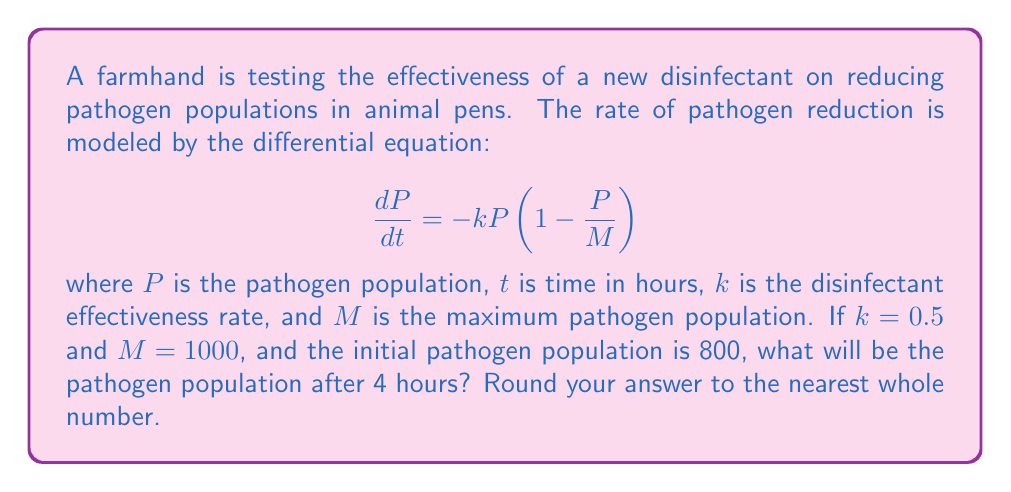Could you help me with this problem? To solve this problem, we need to use the logistic decay model, which is a nonlinear differential equation. Let's approach this step-by-step:

1) The given differential equation is:
   $$\frac{dP}{dt} = -kP(1-\frac{P}{M})$$

2) We're given that $k=0.5$, $M=1000$, and the initial population $P_0=800$.

3) The solution to this differential equation is:
   $$P(t) = \frac{MP_0}{P_0 + (M-P_0)e^{kt}}$$

4) Substituting the known values:
   $$P(t) = \frac{1000 \cdot 800}{800 + (1000-800)e^{0.5t}}$$

5) Simplify:
   $$P(t) = \frac{800000}{800 + 200e^{0.5t}}$$

6) We need to find $P(4)$, so let's substitute $t=4$:
   $$P(4) = \frac{800000}{800 + 200e^{0.5 \cdot 4}}$$

7) Calculate $e^2 \approx 7.389$:
   $$P(4) = \frac{800000}{800 + 200 \cdot 7.389} \approx 491.8$$

8) Rounding to the nearest whole number:
   $$P(4) \approx 492$$

Therefore, after 4 hours, the pathogen population will be approximately 492.
Answer: 492 